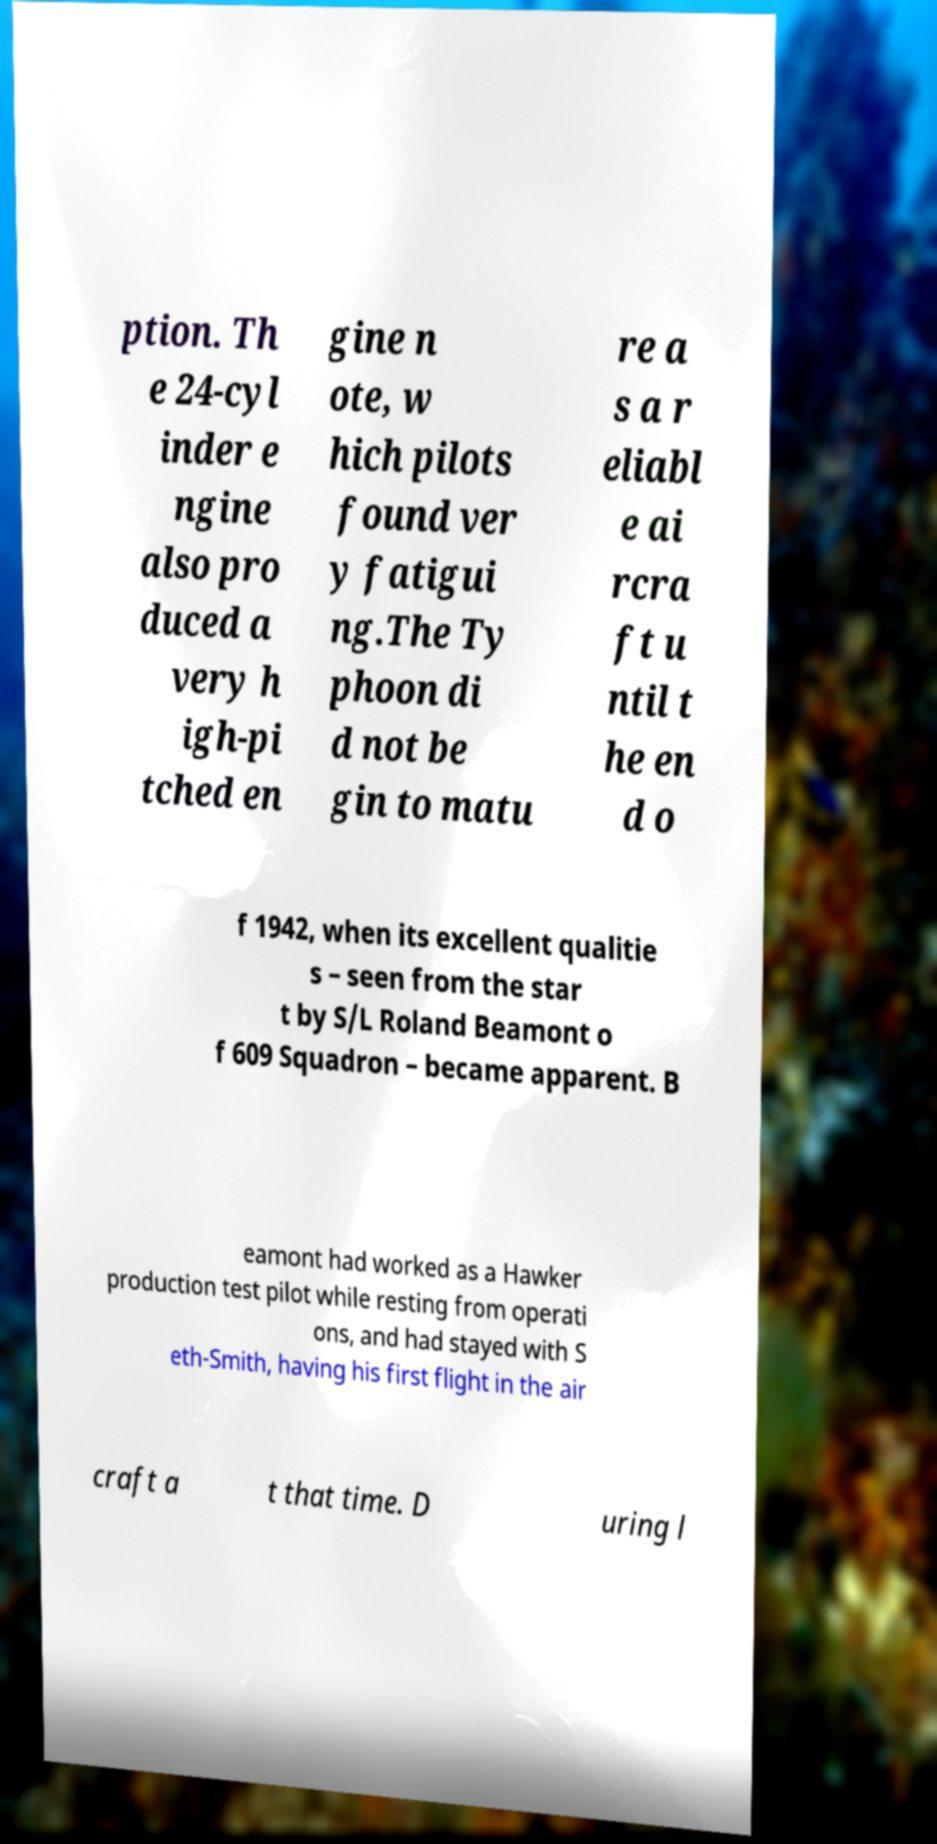Please identify and transcribe the text found in this image. ption. Th e 24-cyl inder e ngine also pro duced a very h igh-pi tched en gine n ote, w hich pilots found ver y fatigui ng.The Ty phoon di d not be gin to matu re a s a r eliabl e ai rcra ft u ntil t he en d o f 1942, when its excellent qualitie s – seen from the star t by S/L Roland Beamont o f 609 Squadron – became apparent. B eamont had worked as a Hawker production test pilot while resting from operati ons, and had stayed with S eth-Smith, having his first flight in the air craft a t that time. D uring l 